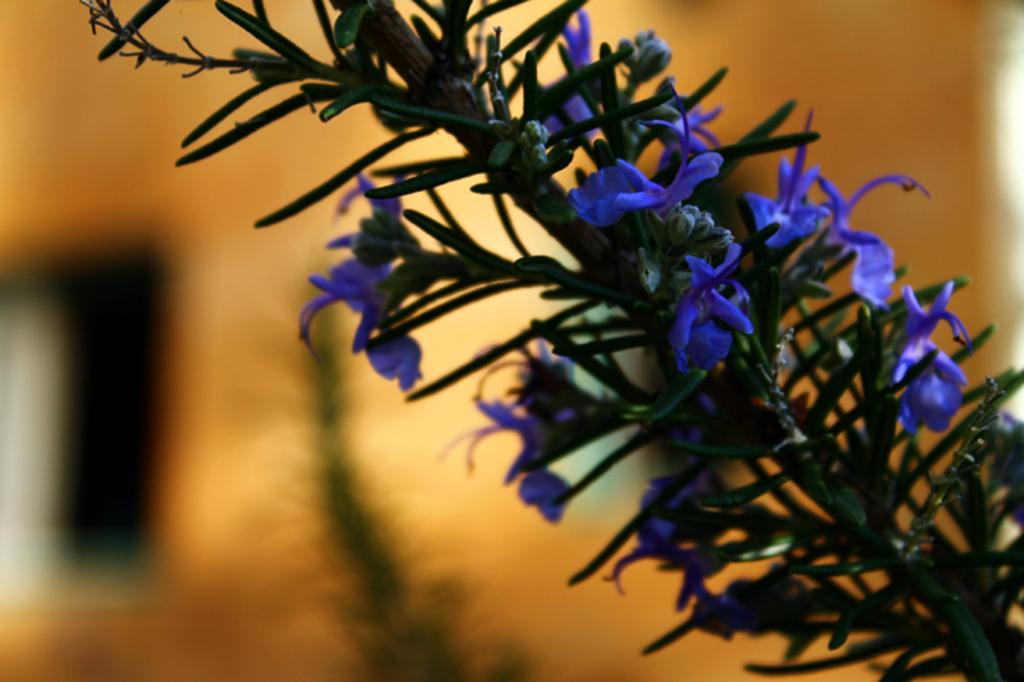What is located in the foreground of the image? There is a plant and flowers in the foreground of the image. What else can be seen in the foreground besides the plant? There are flowers in the foreground of the image. What is visible in the background of the image? There are plants and a wall in the background of the image. How is the background of the image depicted? The background of the image is blurred. How many cherries are hanging from the iron in the image? There are no cherries or iron present in the image. What is the relation between the plant and the flowers in the image? The provided facts do not mention any relation between the plant and the flowers; they are simply both present in the foreground. 